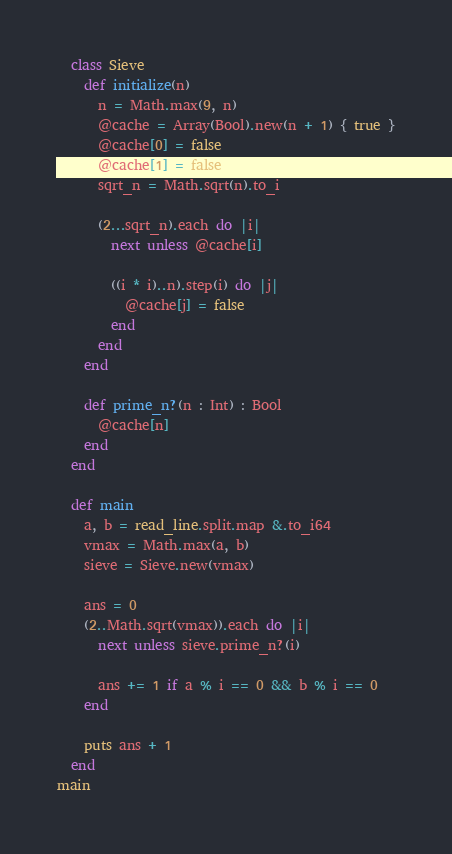<code> <loc_0><loc_0><loc_500><loc_500><_Crystal_>  class Sieve
    def initialize(n)
      n = Math.max(9, n)
      @cache = Array(Bool).new(n + 1) { true }
      @cache[0] = false
      @cache[1] = false
      sqrt_n = Math.sqrt(n).to_i

      (2...sqrt_n).each do |i|
        next unless @cache[i]

        ((i * i)..n).step(i) do |j|
          @cache[j] = false
        end
      end
    end

    def prime_n?(n : Int) : Bool
      @cache[n]
    end
  end

  def main
    a, b = read_line.split.map &.to_i64
    vmax = Math.max(a, b)
    sieve = Sieve.new(vmax)

    ans = 0
    (2..Math.sqrt(vmax)).each do |i|
      next unless sieve.prime_n?(i)

      ans += 1 if a % i == 0 && b % i == 0
    end

    puts ans + 1
  end
main</code> 